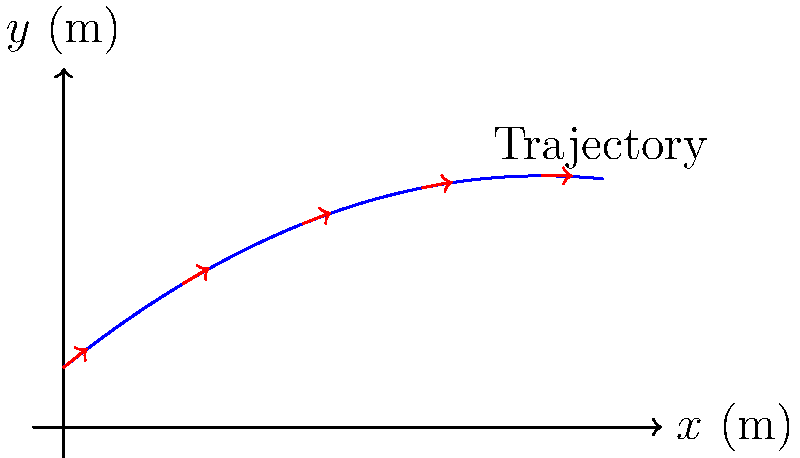As a college president with experience in education, you're observing a volleyball practice. The coach asks for your insight on a serve's trajectory. The graph shows the path of a volleyball serve and its velocity vectors at different points. If the initial velocity of the serve is 15 m/s, what is the approximate horizontal distance the ball travels before hitting the ground? To solve this problem, we'll follow these steps:

1) Observe the graph: The trajectory is parabolic, typical for projectile motion.

2) Identify key points: The ball starts at (0,1) and reaches the ground when y = 0.

3) Use the quadratic formula to find the x-intercept:
   The trajectory function is $y = -0.05x^2 + 0.8x + 1$
   Set $y = 0$: $0 = -0.05x^2 + 0.8x + 1$
   
   $ax^2 + bx + c = 0$, where $a = -0.05$, $b = 0.8$, and $c = 1$
   
   $x = \frac{-b \pm \sqrt{b^2 - 4ac}}{2a}$

4) Calculate:
   $x = \frac{-0.8 \pm \sqrt{0.8^2 - 4(-0.05)(1)}}{2(-0.05)}$
   $x \approx 9.03$ or $x \approx -6.03$ (discard negative solution)

5) The horizontal distance is approximately 9.03 meters.

Note: The initial velocity of 15 m/s is not directly used in this calculation but provides context for the serve's power.
Answer: 9.03 meters 